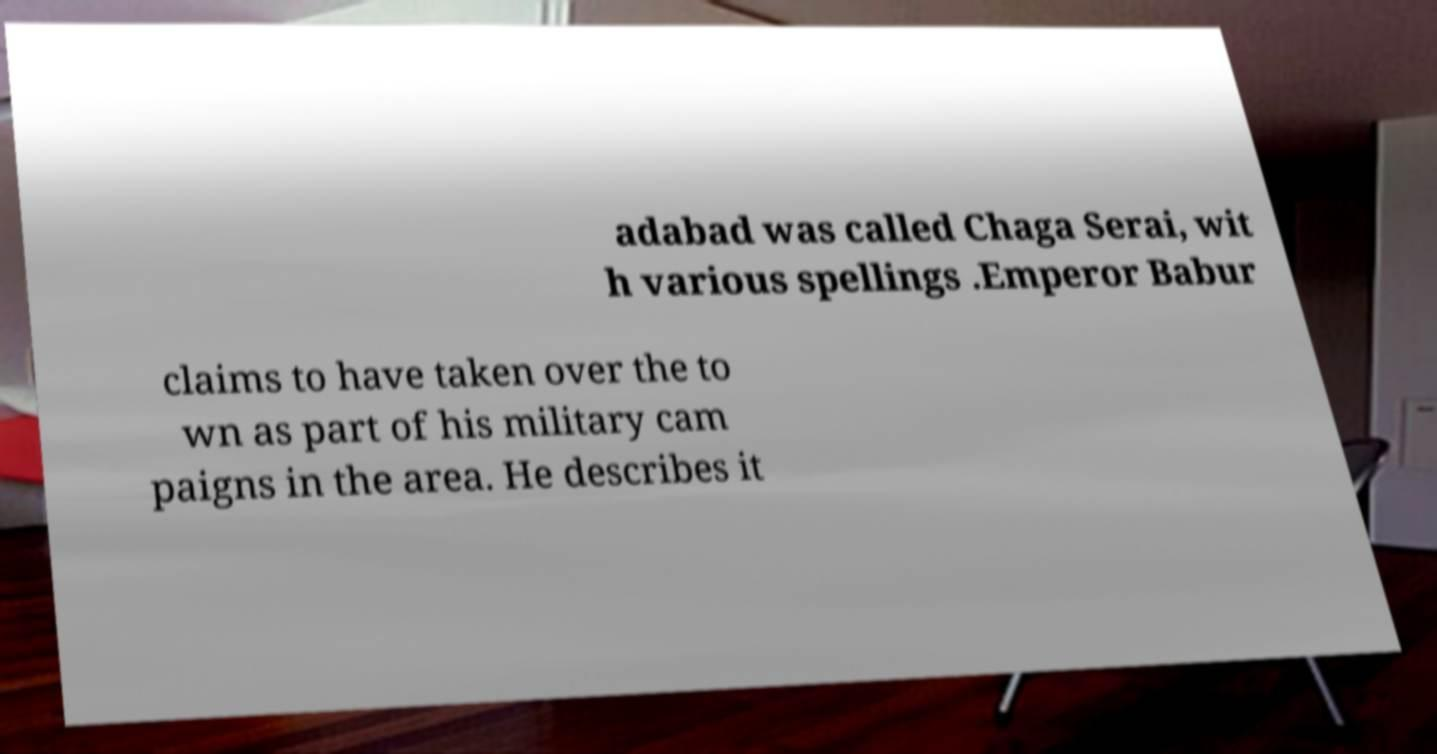I need the written content from this picture converted into text. Can you do that? adabad was called Chaga Serai, wit h various spellings .Emperor Babur claims to have taken over the to wn as part of his military cam paigns in the area. He describes it 